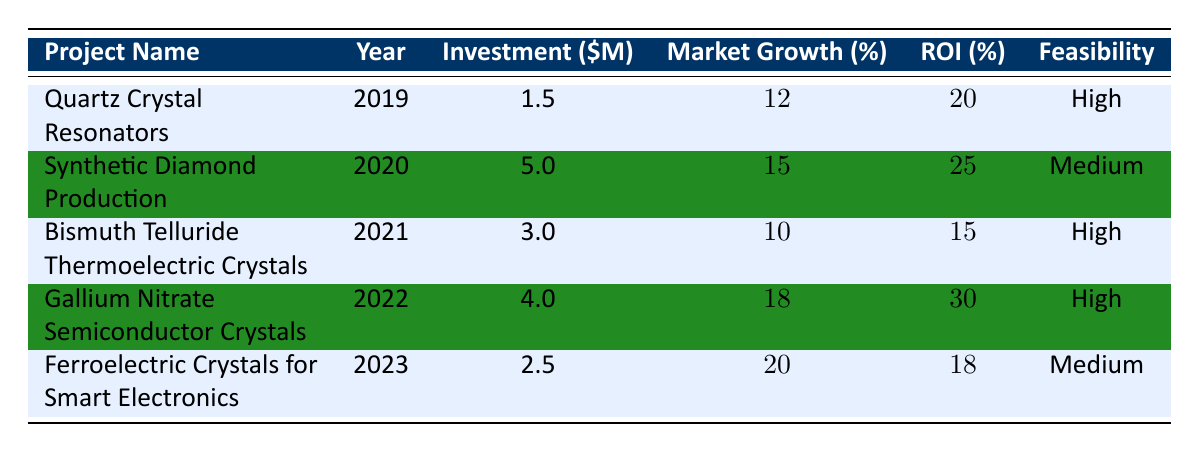What project had the highest expected return on investment? The project with the highest expected return on investment is "Gallium Nitrate Semiconductor Crystals" with an ROI of 30%.
Answer: Gallium Nitrate Semiconductor Crystals What is the investment required for Bismuth Telluride Thermoelectric Crystals? The investment required for Bismuth Telluride Thermoelectric Crystals is 3 million USD.
Answer: 3 million USD Which project was proposed in 2023? The project proposed in 2023 is "Ferroelectric Crystals for Smart Electronics."
Answer: Ferroelectric Crystals for Smart Electronics How many projects have a feasibility rating of High? There are 4 projects with a feasibility rating of High: "Quartz Crystal Resonators," "Bismuth Telluride Thermoelectric Crystals," "Gallium Nitrate Semiconductor Crystals," and "Gallium Nitrate Semiconductor Crystals."
Answer: 4 What is the average market growth percentage of all projects? The average market growth percentage is calculated by summing all the percentages (12 + 15 + 10 + 18 + 20 = 75) and dividing by the number of projects (5), resulting in 75/5 = 15%.
Answer: 15% Is the expected return on investment for Ferroelectric Crystals for Smart Electronics greater than 15%? Yes, the expected return on investment for Ferroelectric Crystals for Smart Electronics is 18%, which is greater than 15%.
Answer: Yes Was the investment required for Synthetic Diamond Production the highest or lowest among the projects? The investment required for Synthetic Diamond Production is the highest at 5 million USD compared to the others.
Answer: Highest In which year was the project with the lowest projected market growth proposed? The project with the lowest projected market growth (10%) is "Bismuth Telluride Thermoelectric Crystals," proposed in 2021.
Answer: 2021 